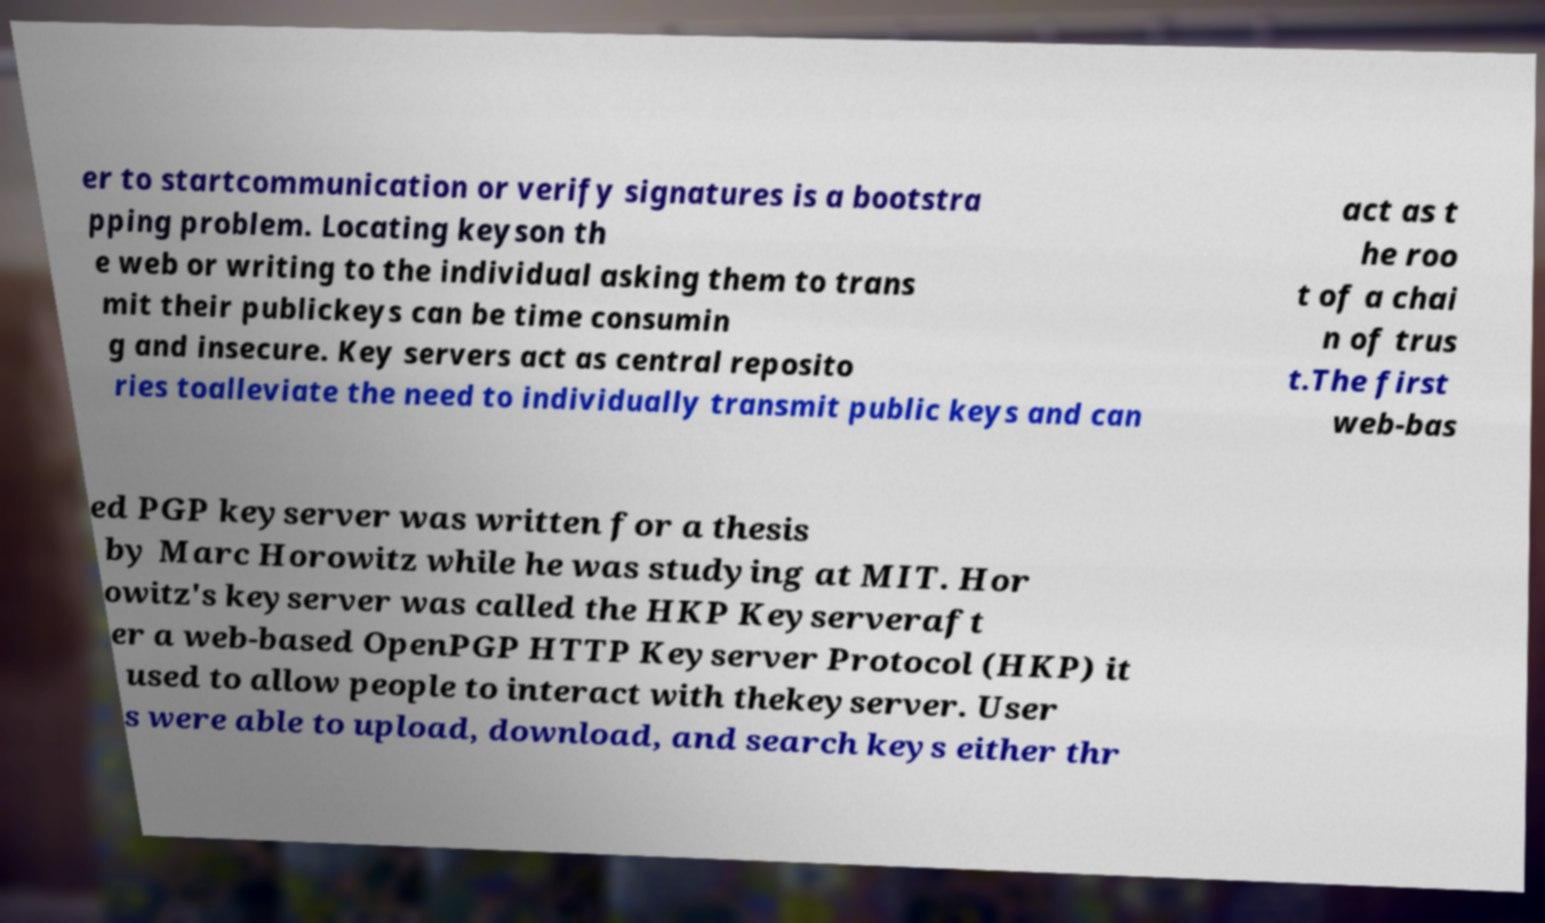Can you accurately transcribe the text from the provided image for me? er to startcommunication or verify signatures is a bootstra pping problem. Locating keyson th e web or writing to the individual asking them to trans mit their publickeys can be time consumin g and insecure. Key servers act as central reposito ries toalleviate the need to individually transmit public keys and can act as t he roo t of a chai n of trus t.The first web-bas ed PGP keyserver was written for a thesis by Marc Horowitz while he was studying at MIT. Hor owitz's keyserver was called the HKP Keyserveraft er a web-based OpenPGP HTTP Keyserver Protocol (HKP) it used to allow people to interact with thekeyserver. User s were able to upload, download, and search keys either thr 